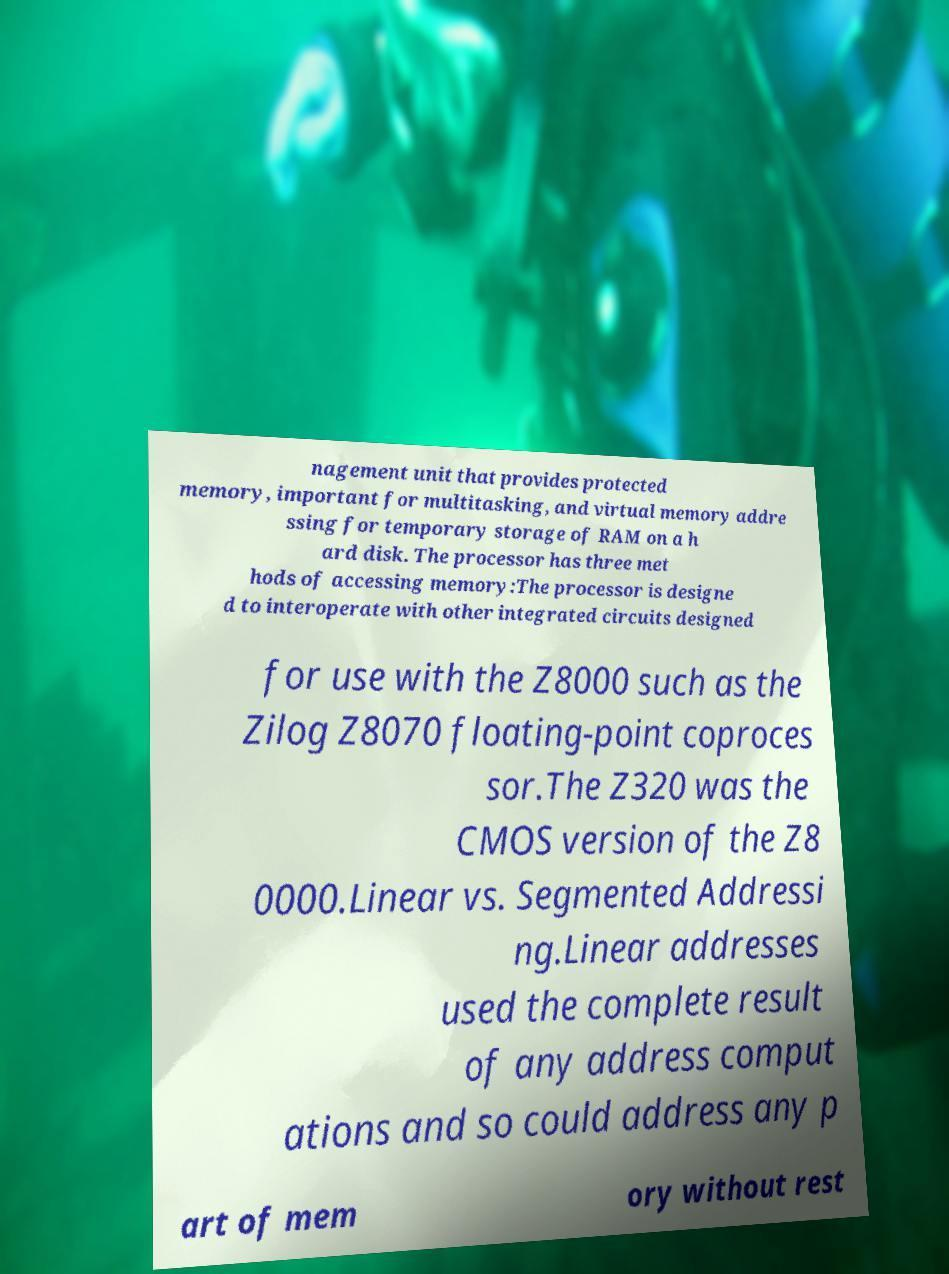Please read and relay the text visible in this image. What does it say? nagement unit that provides protected memory, important for multitasking, and virtual memory addre ssing for temporary storage of RAM on a h ard disk. The processor has three met hods of accessing memory:The processor is designe d to interoperate with other integrated circuits designed for use with the Z8000 such as the Zilog Z8070 floating-point coproces sor.The Z320 was the CMOS version of the Z8 0000.Linear vs. Segmented Addressi ng.Linear addresses used the complete result of any address comput ations and so could address any p art of mem ory without rest 